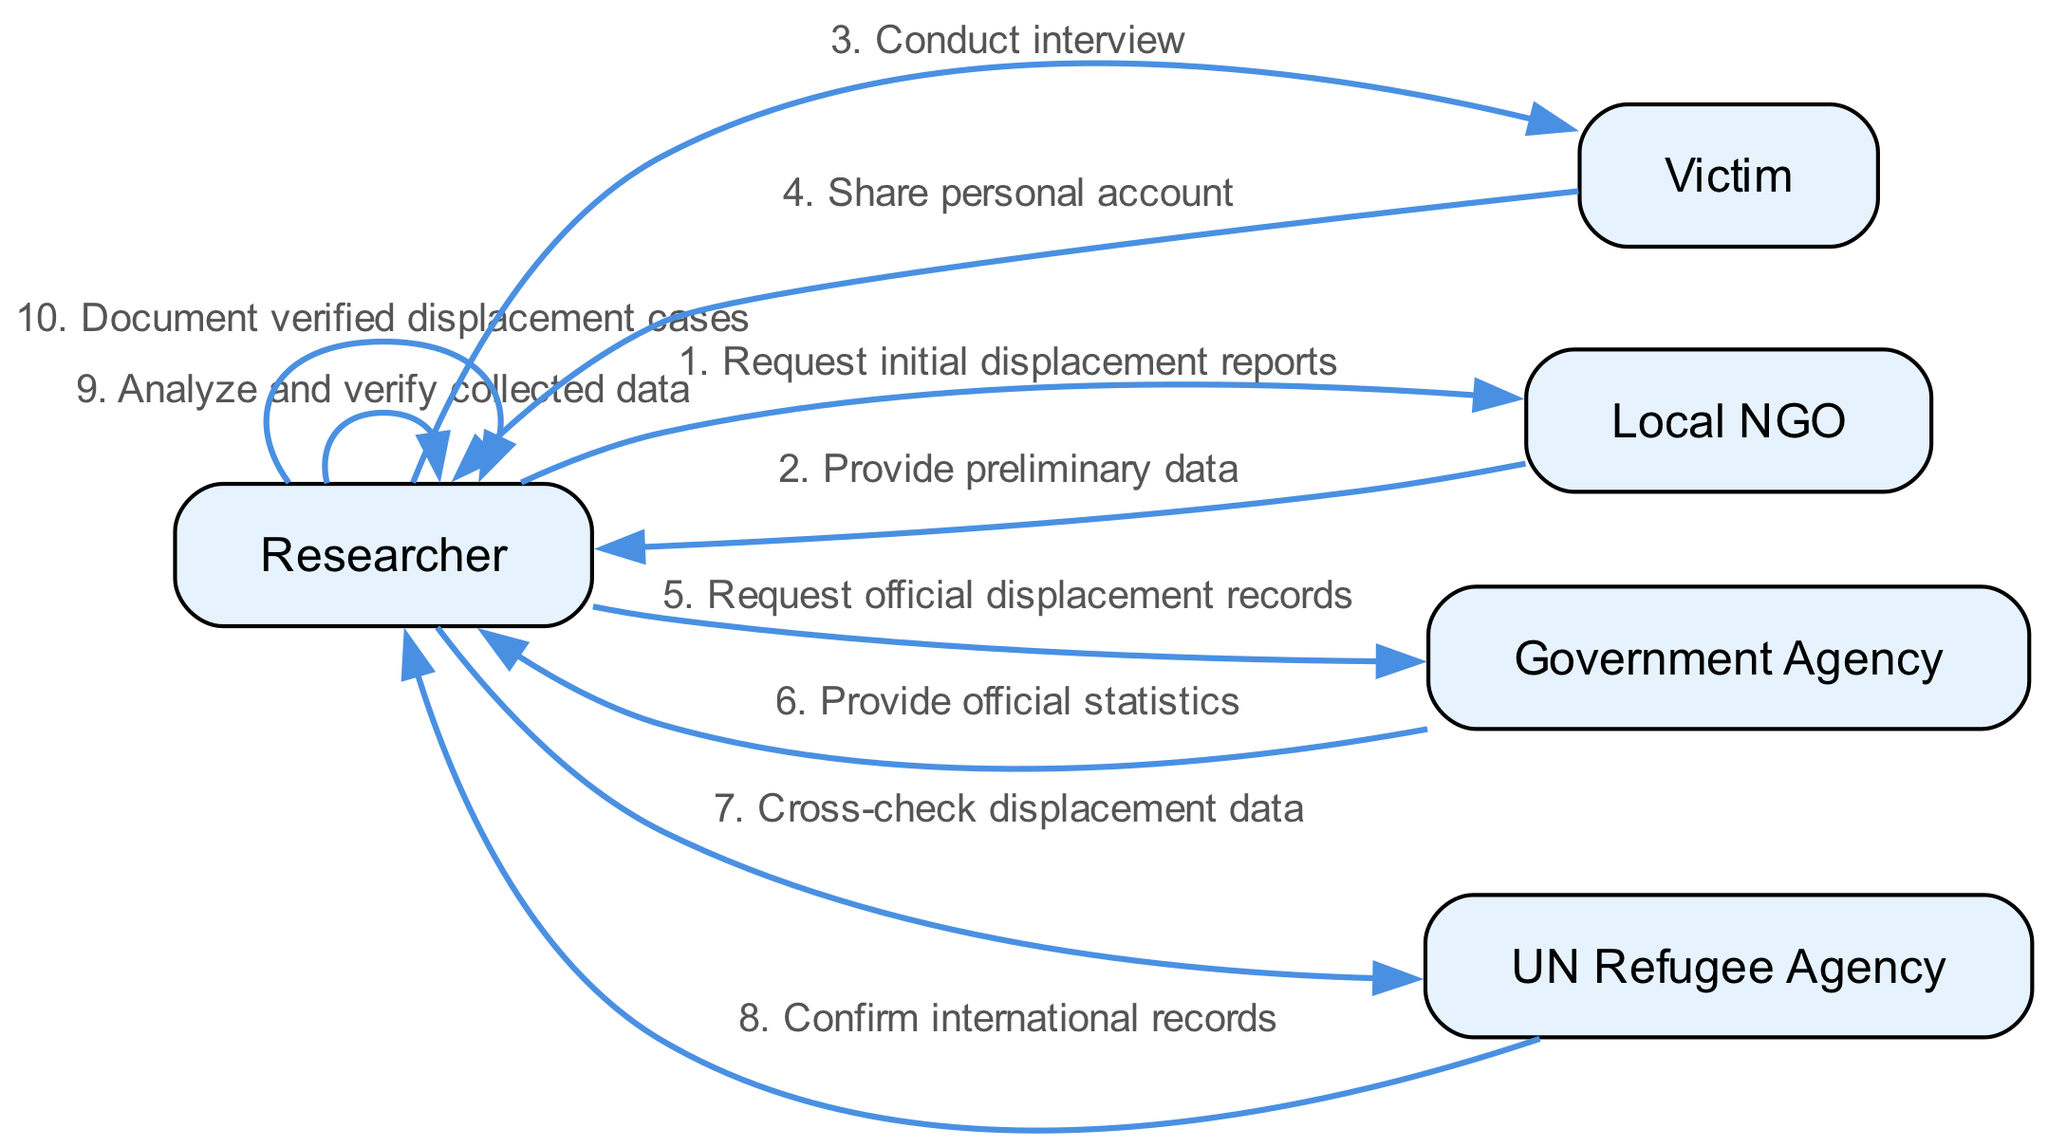What is the first actor to engage in the workflow? The first actor in the workflow is the Researcher, as they initiate the process by requesting initial displacement reports from the Local NGO.
Answer: Researcher How many total interactions are shown in the sequence? There are ten interactions in total represented in the sequence of the diagram. Each interaction connects an actor with a message exchanged.
Answer: 10 What message does the Victim share with the Researcher? The message shared by the Victim with the Researcher is "Share personal account" during their interview.
Answer: Share personal account Which actor confirms international records? The UN Refugee Agency is the actor that confirms international records, providing verification for data cross-checked by the Researcher.
Answer: UN Refugee Agency Which step involves the verification of collected data? The Researcher is responsible for the step where they analyze and verify the collected data as indicated in the sequence.
Answer: Analyze and verify collected data What is the final action taken by the Researcher in the process? The final action taken by the Researcher is to "Document verified displacement cases," completing the workflow of the diagram.
Answer: Document verified displacement cases Identify the actor that provides the first data response. The Local NGO is the actor that responds first by providing preliminary data to the Researcher after the initial request.
Answer: Local NGO How does the Researcher validate the statistics received? The Researcher cross-checks the displacement data with the UN Refugee Agency, which ultimately confirms the international records for validation.
Answer: Cross-check displacement data 